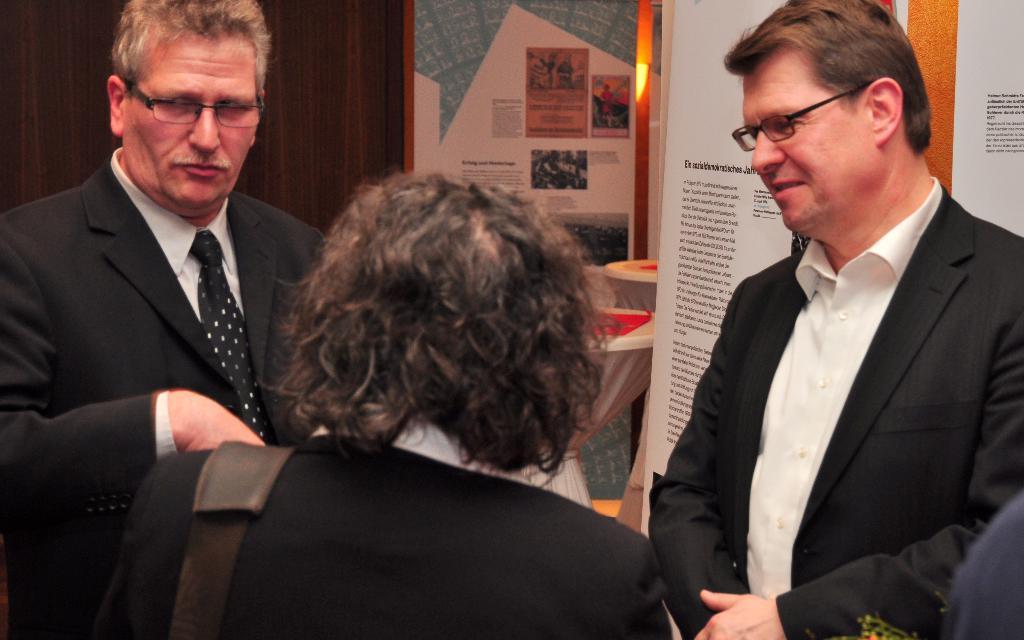Please provide a concise description of this image. In this image I can see three persons are standing. In the background I can see a wall, mirror, tables and boards. This image is taken may be in a hall. 